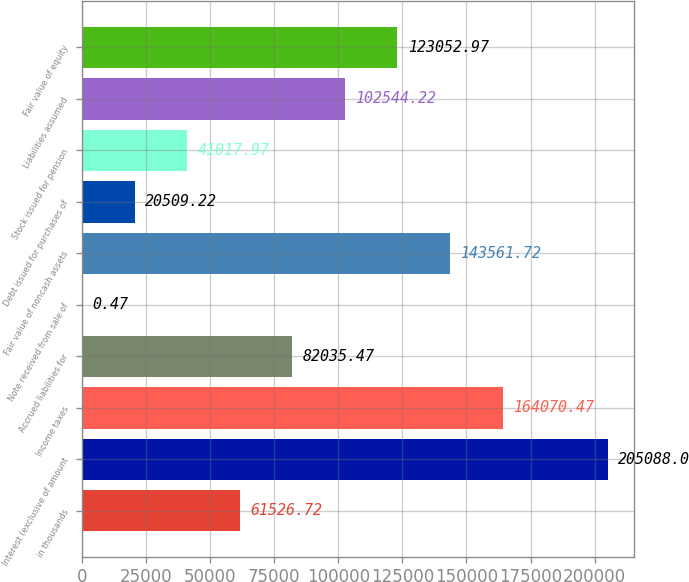Convert chart to OTSL. <chart><loc_0><loc_0><loc_500><loc_500><bar_chart><fcel>in thousands<fcel>Interest (exclusive of amount<fcel>Income taxes<fcel>Accrued liabilities for<fcel>Note received from sale of<fcel>Fair value of noncash assets<fcel>Debt issued for purchases of<fcel>Stock issued for pension<fcel>Liabilities assumed<fcel>Fair value of equity<nl><fcel>61526.7<fcel>205088<fcel>164070<fcel>82035.5<fcel>0.47<fcel>143562<fcel>20509.2<fcel>41018<fcel>102544<fcel>123053<nl></chart> 